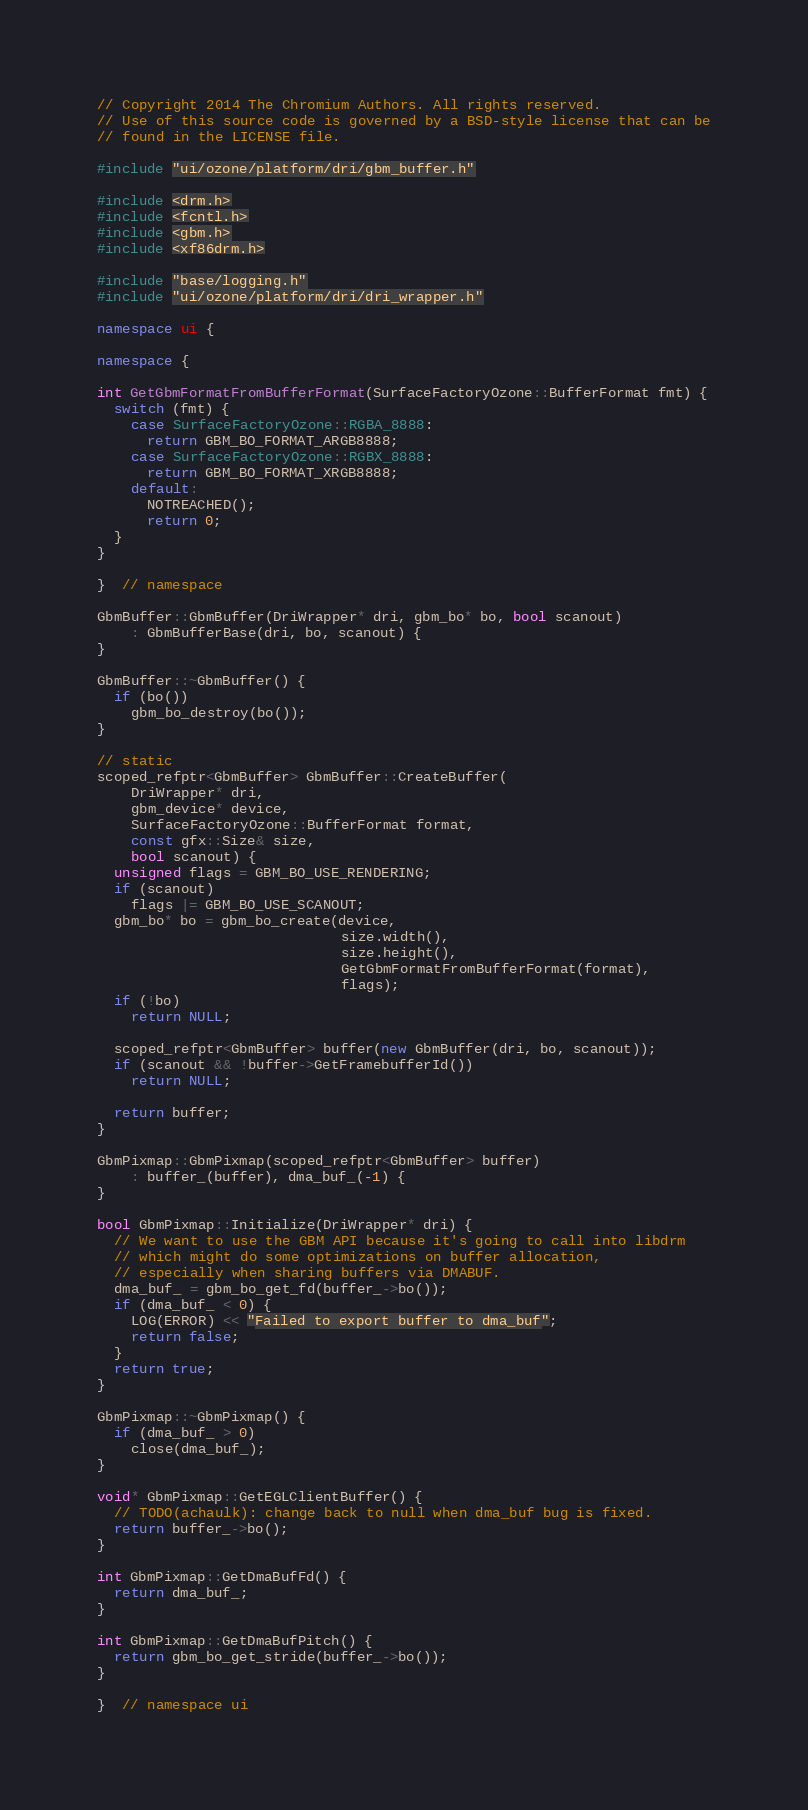<code> <loc_0><loc_0><loc_500><loc_500><_C++_>// Copyright 2014 The Chromium Authors. All rights reserved.
// Use of this source code is governed by a BSD-style license that can be
// found in the LICENSE file.

#include "ui/ozone/platform/dri/gbm_buffer.h"

#include <drm.h>
#include <fcntl.h>
#include <gbm.h>
#include <xf86drm.h>

#include "base/logging.h"
#include "ui/ozone/platform/dri/dri_wrapper.h"

namespace ui {

namespace {

int GetGbmFormatFromBufferFormat(SurfaceFactoryOzone::BufferFormat fmt) {
  switch (fmt) {
    case SurfaceFactoryOzone::RGBA_8888:
      return GBM_BO_FORMAT_ARGB8888;
    case SurfaceFactoryOzone::RGBX_8888:
      return GBM_BO_FORMAT_XRGB8888;
    default:
      NOTREACHED();
      return 0;
  }
}

}  // namespace

GbmBuffer::GbmBuffer(DriWrapper* dri, gbm_bo* bo, bool scanout)
    : GbmBufferBase(dri, bo, scanout) {
}

GbmBuffer::~GbmBuffer() {
  if (bo())
    gbm_bo_destroy(bo());
}

// static
scoped_refptr<GbmBuffer> GbmBuffer::CreateBuffer(
    DriWrapper* dri,
    gbm_device* device,
    SurfaceFactoryOzone::BufferFormat format,
    const gfx::Size& size,
    bool scanout) {
  unsigned flags = GBM_BO_USE_RENDERING;
  if (scanout)
    flags |= GBM_BO_USE_SCANOUT;
  gbm_bo* bo = gbm_bo_create(device,
                             size.width(),
                             size.height(),
                             GetGbmFormatFromBufferFormat(format),
                             flags);
  if (!bo)
    return NULL;

  scoped_refptr<GbmBuffer> buffer(new GbmBuffer(dri, bo, scanout));
  if (scanout && !buffer->GetFramebufferId())
    return NULL;

  return buffer;
}

GbmPixmap::GbmPixmap(scoped_refptr<GbmBuffer> buffer)
    : buffer_(buffer), dma_buf_(-1) {
}

bool GbmPixmap::Initialize(DriWrapper* dri) {
  // We want to use the GBM API because it's going to call into libdrm
  // which might do some optimizations on buffer allocation,
  // especially when sharing buffers via DMABUF.
  dma_buf_ = gbm_bo_get_fd(buffer_->bo());
  if (dma_buf_ < 0) {
    LOG(ERROR) << "Failed to export buffer to dma_buf";
    return false;
  }
  return true;
}

GbmPixmap::~GbmPixmap() {
  if (dma_buf_ > 0)
    close(dma_buf_);
}

void* GbmPixmap::GetEGLClientBuffer() {
  // TODO(achaulk): change back to null when dma_buf bug is fixed.
  return buffer_->bo();
}

int GbmPixmap::GetDmaBufFd() {
  return dma_buf_;
}

int GbmPixmap::GetDmaBufPitch() {
  return gbm_bo_get_stride(buffer_->bo());
}

}  // namespace ui
</code> 